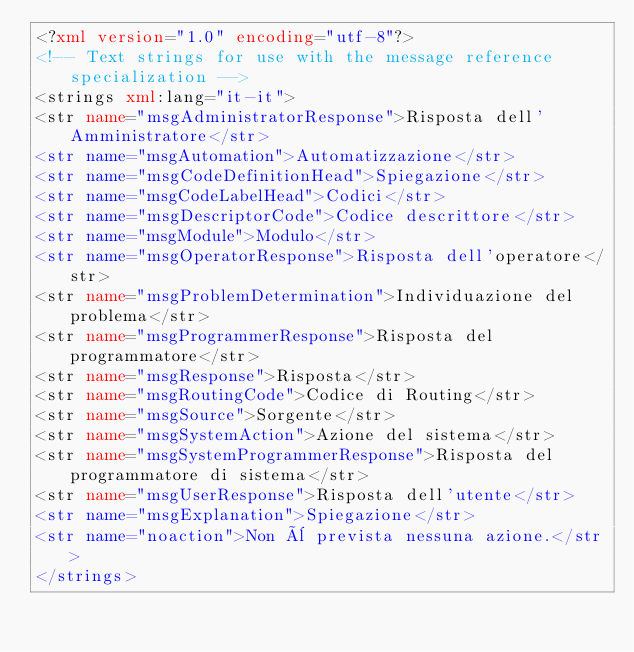<code> <loc_0><loc_0><loc_500><loc_500><_XML_><?xml version="1.0" encoding="utf-8"?>
<!-- Text strings for use with the message reference specialization -->
<strings xml:lang="it-it">
<str name="msgAdministratorResponse">Risposta dell'Amministratore</str>
<str name="msgAutomation">Automatizzazione</str>
<str name="msgCodeDefinitionHead">Spiegazione</str>
<str name="msgCodeLabelHead">Codici</str>
<str name="msgDescriptorCode">Codice descrittore</str>
<str name="msgModule">Modulo</str>
<str name="msgOperatorResponse">Risposta dell'operatore</str>
<str name="msgProblemDetermination">Individuazione del problema</str>
<str name="msgProgrammerResponse">Risposta del programmatore</str>
<str name="msgResponse">Risposta</str>
<str name="msgRoutingCode">Codice di Routing</str>
<str name="msgSource">Sorgente</str>
<str name="msgSystemAction">Azione del sistema</str>
<str name="msgSystemProgrammerResponse">Risposta del programmatore di sistema</str>
<str name="msgUserResponse">Risposta dell'utente</str>
<str name="msgExplanation">Spiegazione</str>
<str name="noaction">Non è prevista nessuna azione.</str>
</strings>
</code> 